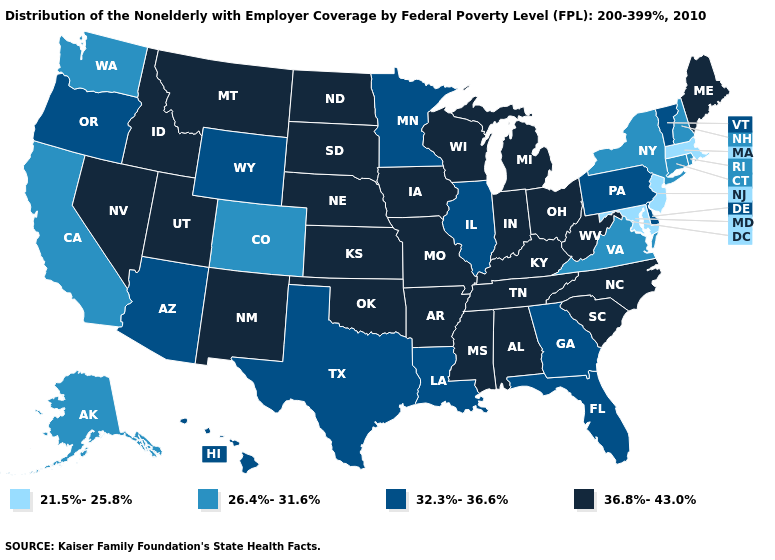What is the value of Rhode Island?
Keep it brief. 26.4%-31.6%. Does Delaware have a lower value than New Hampshire?
Answer briefly. No. Name the states that have a value in the range 21.5%-25.8%?
Answer briefly. Maryland, Massachusetts, New Jersey. Among the states that border Oklahoma , does Colorado have the lowest value?
Short answer required. Yes. Name the states that have a value in the range 36.8%-43.0%?
Give a very brief answer. Alabama, Arkansas, Idaho, Indiana, Iowa, Kansas, Kentucky, Maine, Michigan, Mississippi, Missouri, Montana, Nebraska, Nevada, New Mexico, North Carolina, North Dakota, Ohio, Oklahoma, South Carolina, South Dakota, Tennessee, Utah, West Virginia, Wisconsin. Which states have the lowest value in the USA?
Give a very brief answer. Maryland, Massachusetts, New Jersey. Which states have the highest value in the USA?
Be succinct. Alabama, Arkansas, Idaho, Indiana, Iowa, Kansas, Kentucky, Maine, Michigan, Mississippi, Missouri, Montana, Nebraska, Nevada, New Mexico, North Carolina, North Dakota, Ohio, Oklahoma, South Carolina, South Dakota, Tennessee, Utah, West Virginia, Wisconsin. How many symbols are there in the legend?
Be succinct. 4. What is the value of Ohio?
Answer briefly. 36.8%-43.0%. Name the states that have a value in the range 36.8%-43.0%?
Be succinct. Alabama, Arkansas, Idaho, Indiana, Iowa, Kansas, Kentucky, Maine, Michigan, Mississippi, Missouri, Montana, Nebraska, Nevada, New Mexico, North Carolina, North Dakota, Ohio, Oklahoma, South Carolina, South Dakota, Tennessee, Utah, West Virginia, Wisconsin. Which states hav the highest value in the MidWest?
Answer briefly. Indiana, Iowa, Kansas, Michigan, Missouri, Nebraska, North Dakota, Ohio, South Dakota, Wisconsin. What is the highest value in the West ?
Short answer required. 36.8%-43.0%. What is the highest value in the Northeast ?
Give a very brief answer. 36.8%-43.0%. What is the value of Mississippi?
Be succinct. 36.8%-43.0%. Is the legend a continuous bar?
Answer briefly. No. 